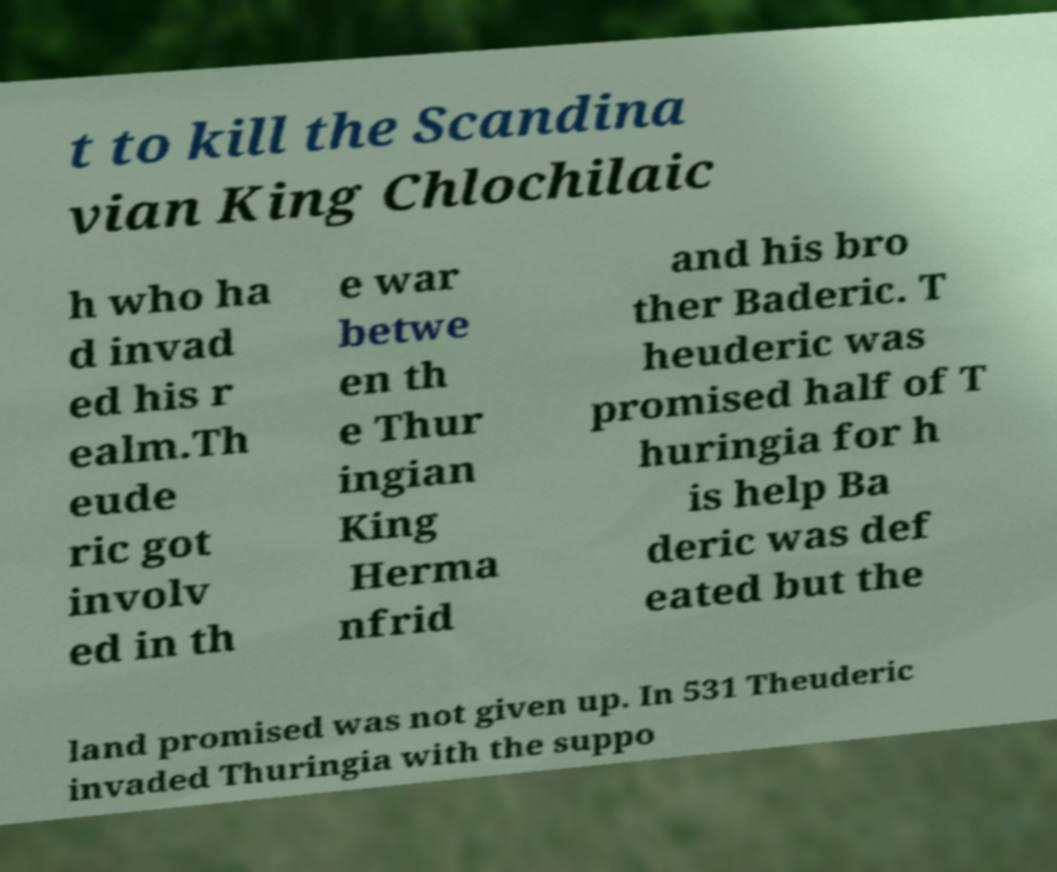Could you extract and type out the text from this image? t to kill the Scandina vian King Chlochilaic h who ha d invad ed his r ealm.Th eude ric got involv ed in th e war betwe en th e Thur ingian King Herma nfrid and his bro ther Baderic. T heuderic was promised half of T huringia for h is help Ba deric was def eated but the land promised was not given up. In 531 Theuderic invaded Thuringia with the suppo 